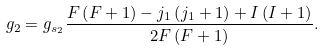<formula> <loc_0><loc_0><loc_500><loc_500>g _ { 2 } = g _ { s _ { 2 } } \frac { F \left ( F + 1 \right ) - j _ { 1 } \left ( j _ { 1 } + 1 \right ) + I \left ( I + 1 \right ) } { 2 F \left ( F + 1 \right ) } .</formula> 